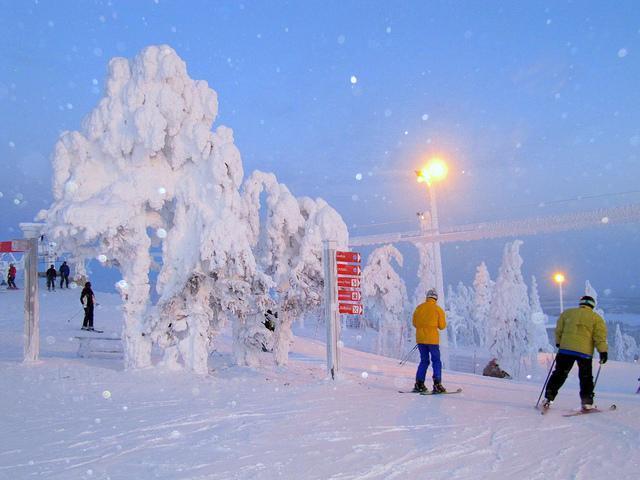How many people are there?
Give a very brief answer. 2. How many orange cars are there in the picture?
Give a very brief answer. 0. 